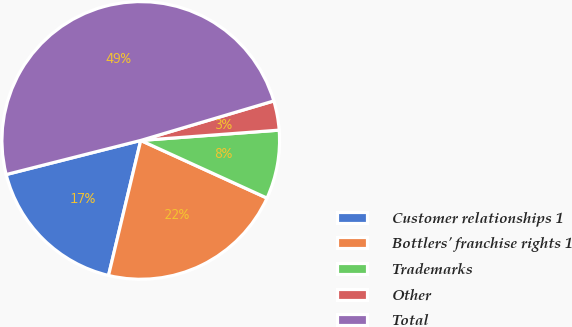<chart> <loc_0><loc_0><loc_500><loc_500><pie_chart><fcel>Customer relationships 1<fcel>Bottlers' franchise rights 1<fcel>Trademarks<fcel>Other<fcel>Total<nl><fcel>17.32%<fcel>21.91%<fcel>8.0%<fcel>3.41%<fcel>49.36%<nl></chart> 